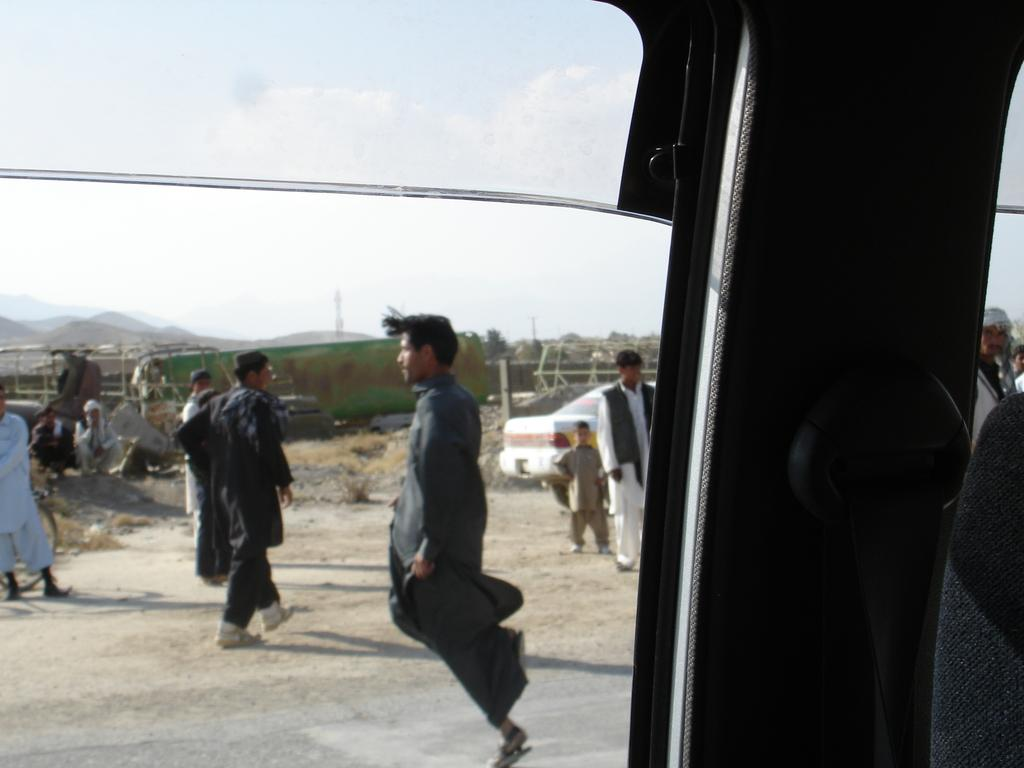What can be seen through the glass window of the vehicle in the image? There is a picture visible through the glass window of the vehicle. What is happening on the ground in the image? There are people standing on the ground. What color is the car in the image? There is a white-colored car in the image. What type of natural features can be seen in the image? There are trees and mountains in the image. What is visible in the sky in the image? The sky is visible in the image. How many balls are being used by the people in the image? There are no balls present in the image; the people are standing on the ground. Can you tell me how the skate is increasing its speed in the image? There is no skate present in the image; it features a picture visible through the glass window of a vehicle, people standing on the ground, a white-colored car, trees, mountains, and a visible sky. 